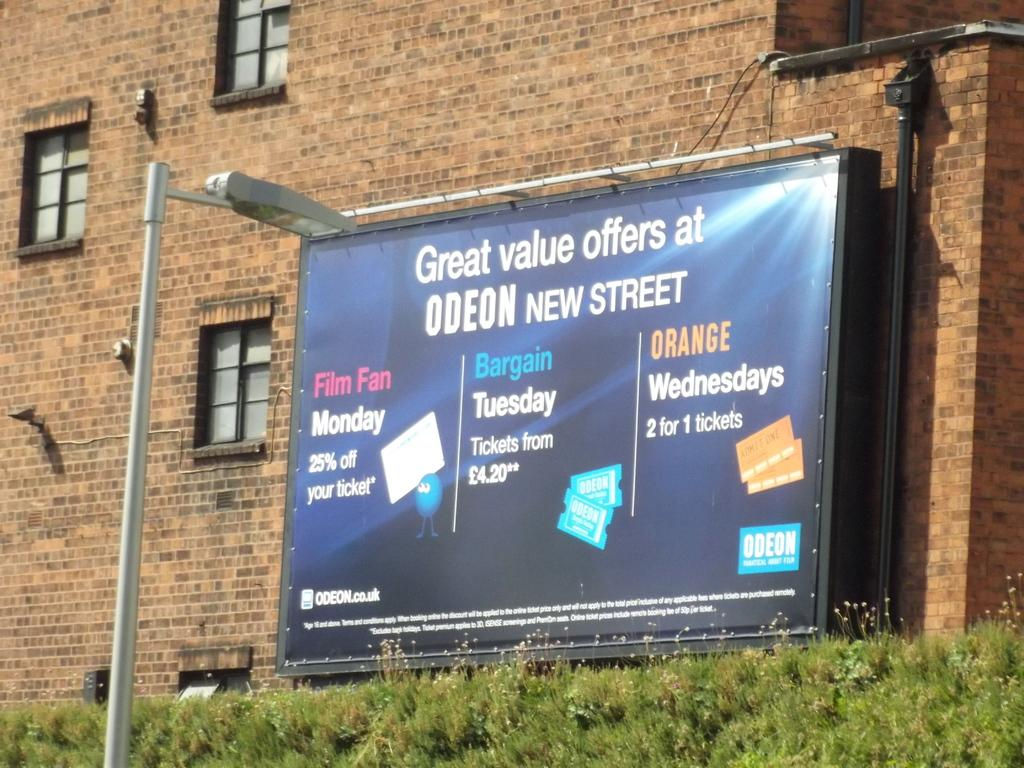Provide a one-sentence caption for the provided image. a billboard for Great Value Offers at Odeon New Street. 